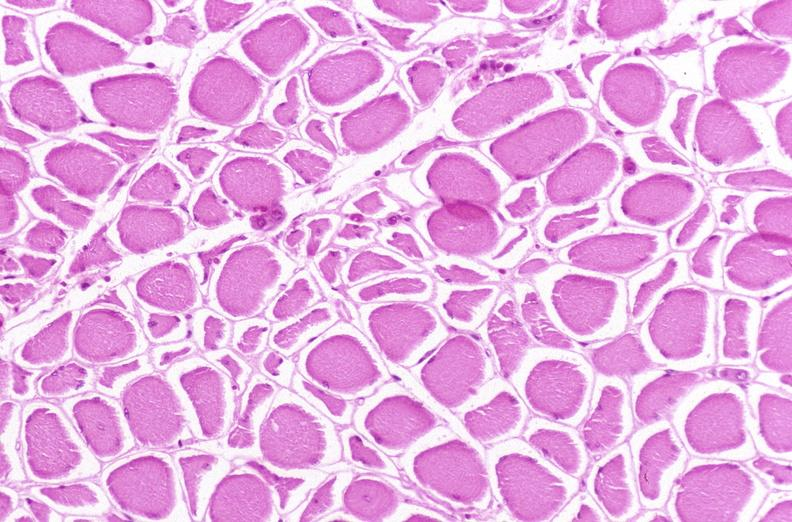what is present?
Answer the question using a single word or phrase. Musculoskeletal 